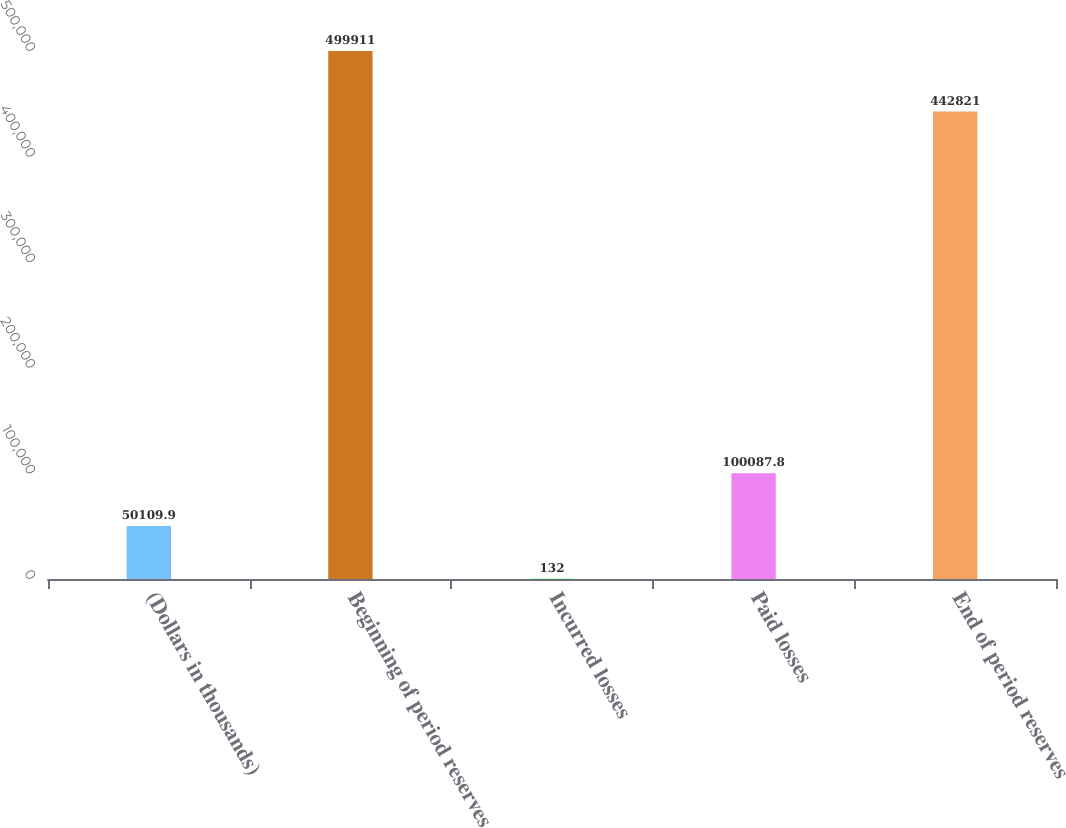Convert chart. <chart><loc_0><loc_0><loc_500><loc_500><bar_chart><fcel>(Dollars in thousands)<fcel>Beginning of period reserves<fcel>Incurred losses<fcel>Paid losses<fcel>End of period reserves<nl><fcel>50109.9<fcel>499911<fcel>132<fcel>100088<fcel>442821<nl></chart> 